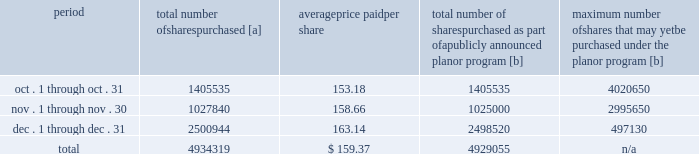Five-year performance comparison 2013 the following graph provides an indicator of cumulative total shareholder returns for the corporation as compared to the peer group index ( described above ) , the dj trans , and the s&p 500 .
The graph assumes that $ 100 was invested in the common stock of union pacific corporation and each index on december 31 , 2008 and that all dividends were reinvested .
The information below is historical in nature and is not necessarily indicative of future performance .
Purchases of equity securities 2013 during 2013 , we repurchased 14996957 shares of our common stock at an average price of $ 152.14 .
The table presents common stock repurchases during each month for the fourth quarter of 2013 : period total number of shares purchased [a] average price paid per share total number of shares purchased as part of a publicly announced plan or program [b] maximum number of shares that may yet be purchased under the plan or program [b] .
[a] total number of shares purchased during the quarter includes approximately 5264 shares delivered or attested to upc by employees to pay stock option exercise prices , satisfy excess tax withholding obligations for stock option exercises or vesting of retention units , and pay withholding obligations for vesting of retention shares .
[b] on april 1 , 2011 , our board of directors authorized the repurchase of up to 40 million shares of our common stock by march 31 , 2014 .
These repurchases may be made on the open market or through other transactions .
Our management has sole discretion with respect to determining the timing and amount of these transactions .
On november 21 , 2013 , the board of directors approved the early renewal of the share repurchase program , authorizing the repurchase of 60 million common shares by december 31 , 2017 .
The new authorization is effective january 1 , 2014 , and replaces the previous authorization , which expired on december 31 , 2013 , three months earlier than its original expiration date. .
What percentage of total shares purchased where purchased in november? 
Computations: (1027840 / 4934319)
Answer: 0.2083. Five-year performance comparison 2013 the following graph provides an indicator of cumulative total shareholder returns for the corporation as compared to the peer group index ( described above ) , the dj trans , and the s&p 500 .
The graph assumes that $ 100 was invested in the common stock of union pacific corporation and each index on december 31 , 2008 and that all dividends were reinvested .
The information below is historical in nature and is not necessarily indicative of future performance .
Purchases of equity securities 2013 during 2013 , we repurchased 14996957 shares of our common stock at an average price of $ 152.14 .
The table presents common stock repurchases during each month for the fourth quarter of 2013 : period total number of shares purchased [a] average price paid per share total number of shares purchased as part of a publicly announced plan or program [b] maximum number of shares that may yet be purchased under the plan or program [b] .
[a] total number of shares purchased during the quarter includes approximately 5264 shares delivered or attested to upc by employees to pay stock option exercise prices , satisfy excess tax withholding obligations for stock option exercises or vesting of retention units , and pay withholding obligations for vesting of retention shares .
[b] on april 1 , 2011 , our board of directors authorized the repurchase of up to 40 million shares of our common stock by march 31 , 2014 .
These repurchases may be made on the open market or through other transactions .
Our management has sole discretion with respect to determining the timing and amount of these transactions .
On november 21 , 2013 , the board of directors approved the early renewal of the share repurchase program , authorizing the repurchase of 60 million common shares by december 31 , 2017 .
The new authorization is effective january 1 , 2014 , and replaces the previous authorization , which expired on december 31 , 2013 , three months earlier than its original expiration date. .
What percentage of total shares purchased where purchased in october? 
Computations: (1405535 / 4934319)
Answer: 0.28485. 